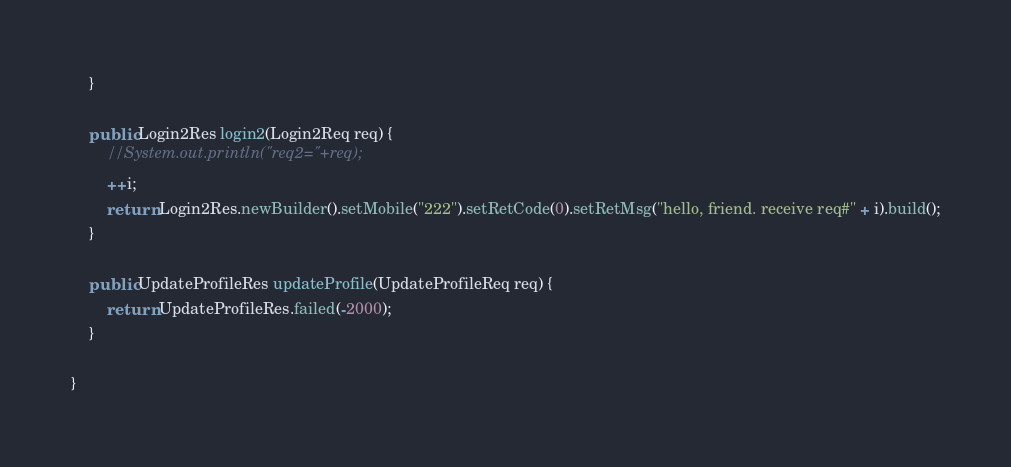Convert code to text. <code><loc_0><loc_0><loc_500><loc_500><_Java_>    }

    public Login2Res login2(Login2Req req) {
        //System.out.println("req2="+req);
        ++i;
        return Login2Res.newBuilder().setMobile("222").setRetCode(0).setRetMsg("hello, friend. receive req#" + i).build();
    }

    public UpdateProfileRes updateProfile(UpdateProfileReq req) {
        return UpdateProfileRes.failed(-2000);
    }

}</code> 